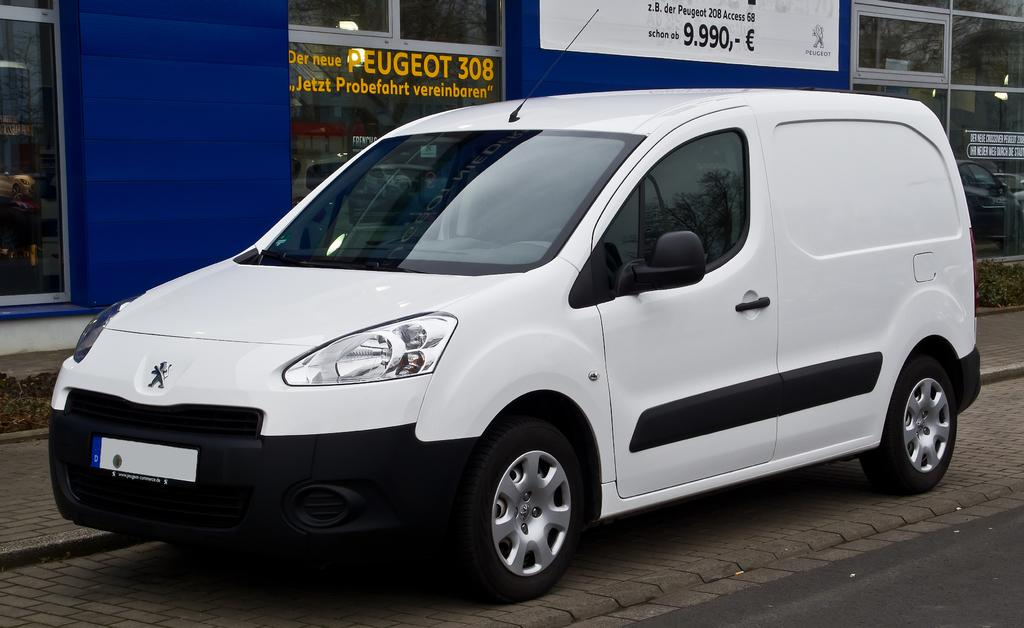<image>
Describe the image concisely. A white and black van is sitting in front of a store that says peugeot 308 on the glass. 